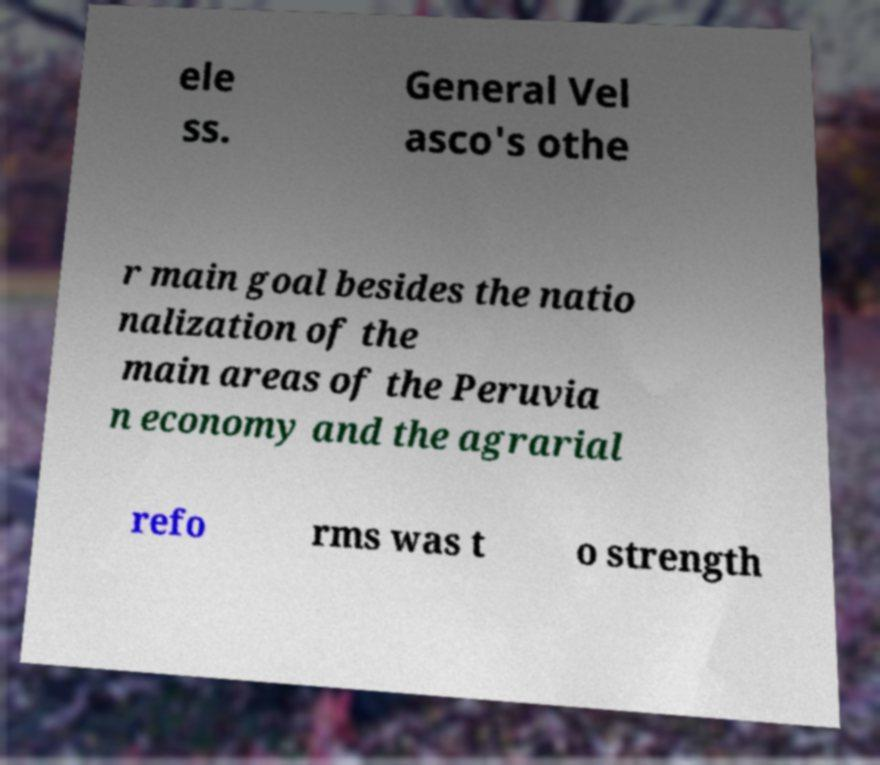I need the written content from this picture converted into text. Can you do that? ele ss. General Vel asco's othe r main goal besides the natio nalization of the main areas of the Peruvia n economy and the agrarial refo rms was t o strength 